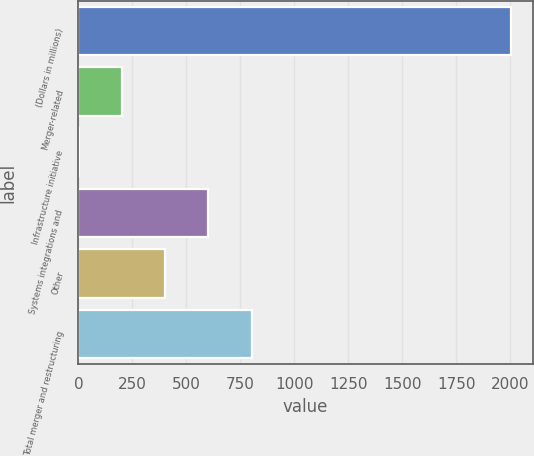<chart> <loc_0><loc_0><loc_500><loc_500><bar_chart><fcel>(Dollars in millions)<fcel>Merger-related<fcel>Infrastructure initiative<fcel>Systems integrations and<fcel>Other<fcel>Total merger and restructuring<nl><fcel>2005<fcel>201.4<fcel>1<fcel>602.2<fcel>401.8<fcel>802.6<nl></chart> 